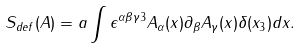<formula> <loc_0><loc_0><loc_500><loc_500>S _ { d e f } ( A ) = a \int \epsilon ^ { \alpha \beta \gamma 3 } A _ { \alpha } ( x ) \partial _ { \beta } A _ { \gamma } ( x ) \delta ( x _ { 3 } ) d x .</formula> 